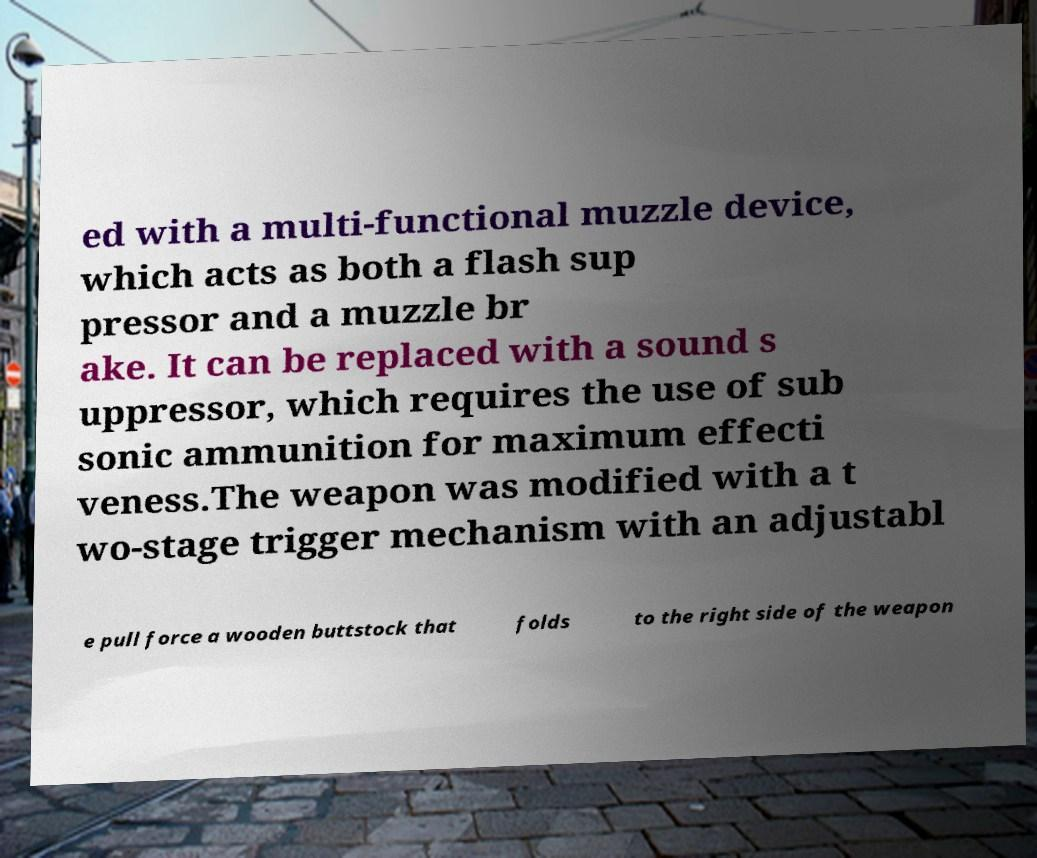Could you extract and type out the text from this image? ed with a multi-functional muzzle device, which acts as both a flash sup pressor and a muzzle br ake. It can be replaced with a sound s uppressor, which requires the use of sub sonic ammunition for maximum effecti veness.The weapon was modified with a t wo-stage trigger mechanism with an adjustabl e pull force a wooden buttstock that folds to the right side of the weapon 